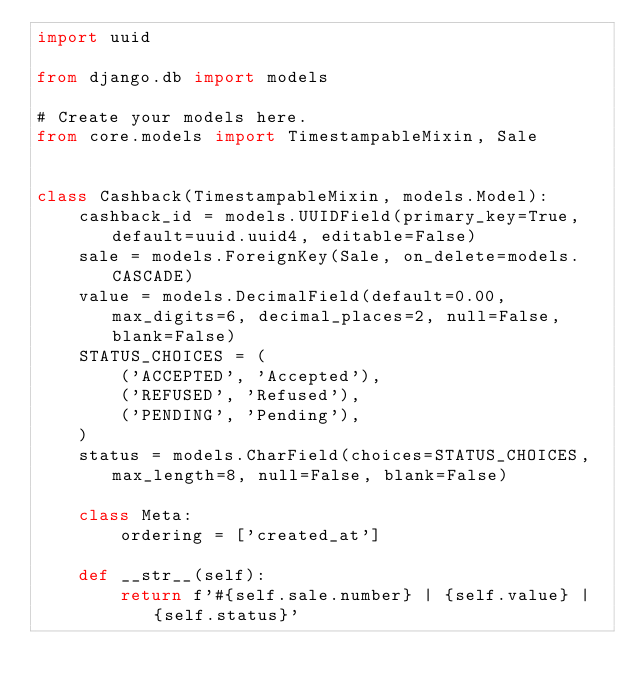<code> <loc_0><loc_0><loc_500><loc_500><_Python_>import uuid

from django.db import models

# Create your models here.
from core.models import TimestampableMixin, Sale


class Cashback(TimestampableMixin, models.Model):
    cashback_id = models.UUIDField(primary_key=True, default=uuid.uuid4, editable=False)
    sale = models.ForeignKey(Sale, on_delete=models.CASCADE)
    value = models.DecimalField(default=0.00, max_digits=6, decimal_places=2, null=False, blank=False)
    STATUS_CHOICES = (
        ('ACCEPTED', 'Accepted'),
        ('REFUSED', 'Refused'),
        ('PENDING', 'Pending'),
    )
    status = models.CharField(choices=STATUS_CHOICES, max_length=8, null=False, blank=False)

    class Meta:
        ordering = ['created_at']

    def __str__(self):
        return f'#{self.sale.number} | {self.value} | {self.status}'</code> 